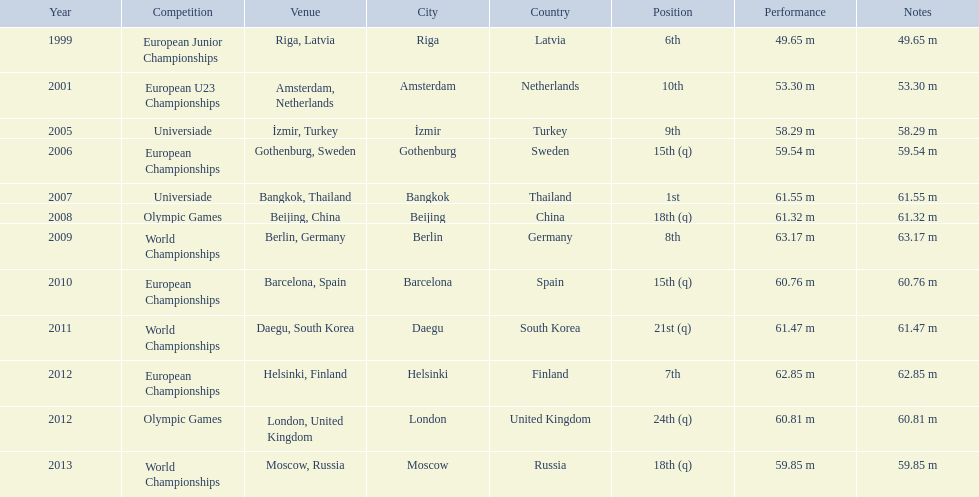Which competitions has gerhard mayer competed in since 1999? European Junior Championships, European U23 Championships, Universiade, European Championships, Universiade, Olympic Games, World Championships, European Championships, World Championships, European Championships, Olympic Games, World Championships. Of these competition, in which ones did he throw at least 60 m? Universiade, Olympic Games, World Championships, European Championships, World Championships, European Championships, Olympic Games. Of these throws, which was his longest? 63.17 m. 